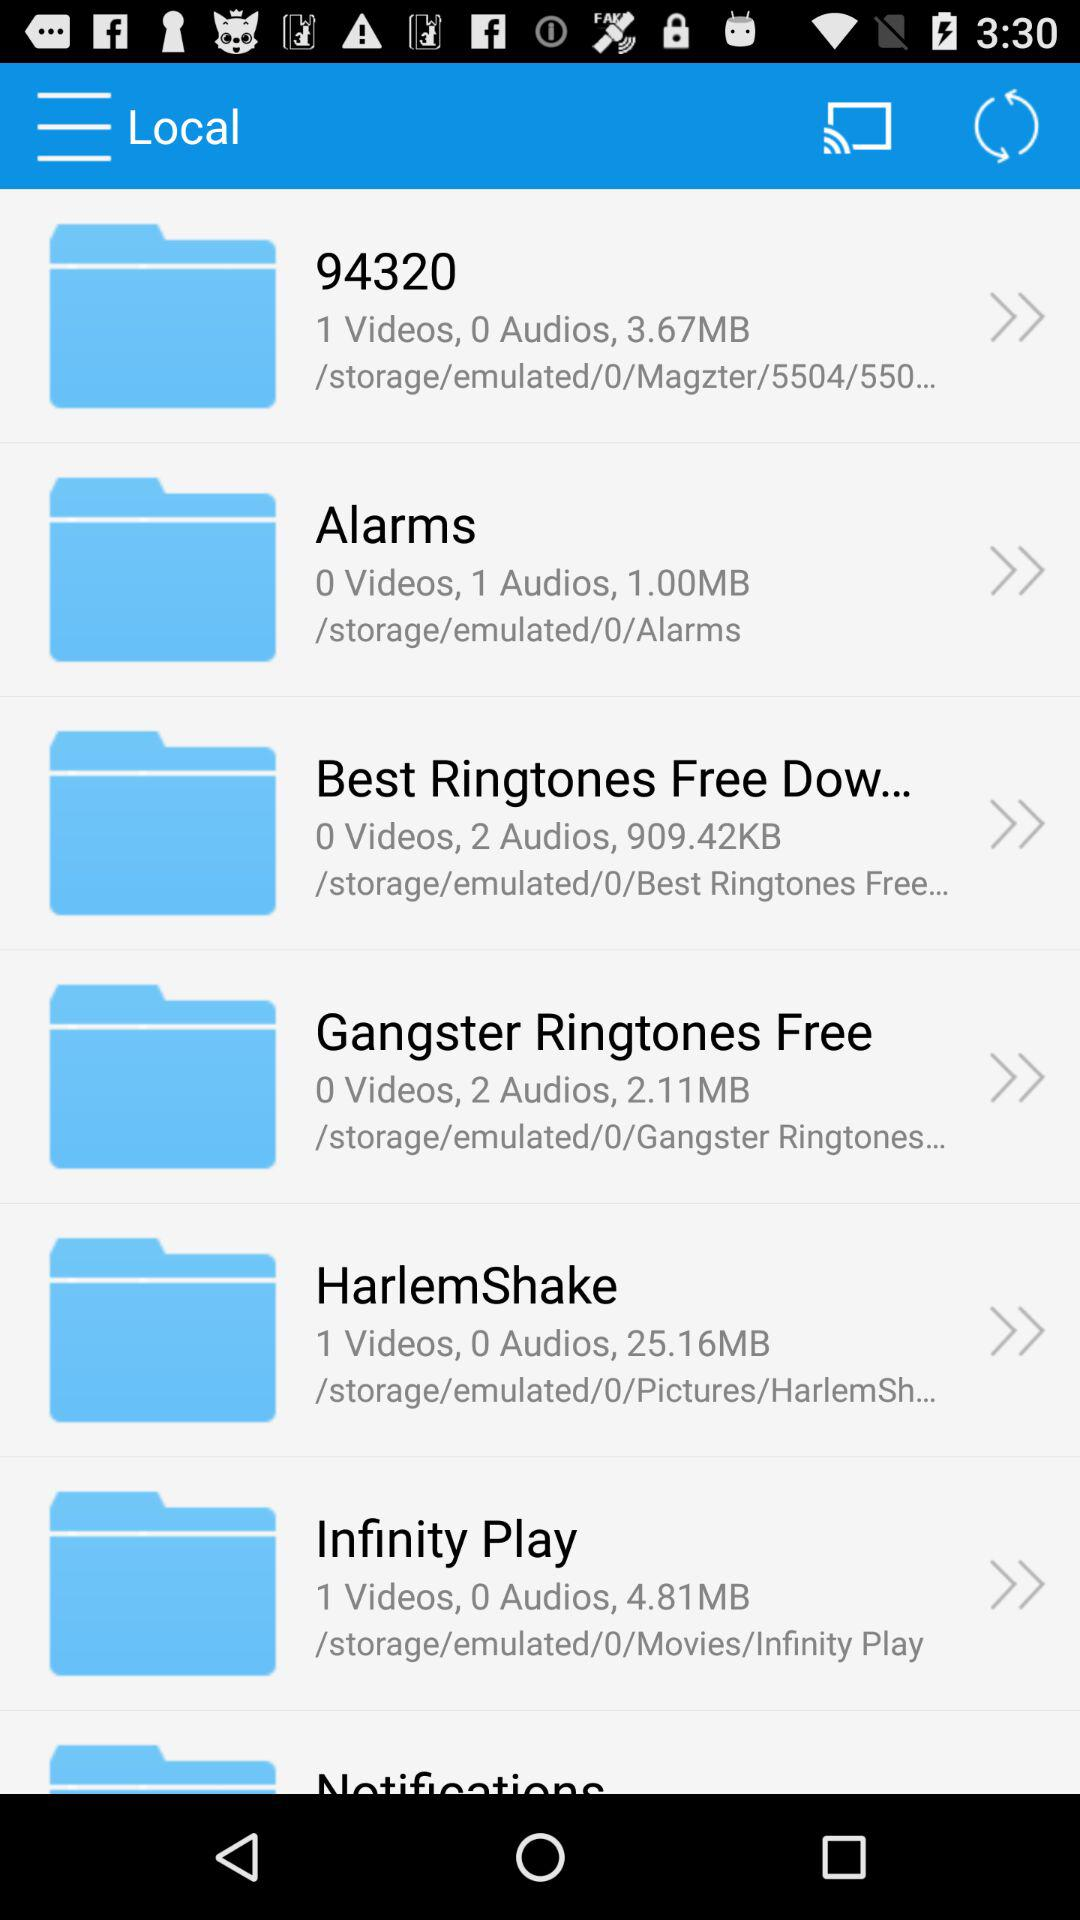How much of the data is stored in "HarlemShake"? The data stored in "HarlemShake" is 25.16 MB. 